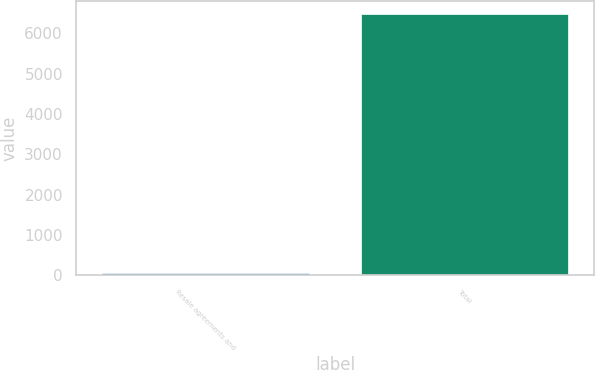Convert chart. <chart><loc_0><loc_0><loc_500><loc_500><bar_chart><fcel>Resale agreements and<fcel>Total<nl><fcel>46<fcel>6490<nl></chart> 